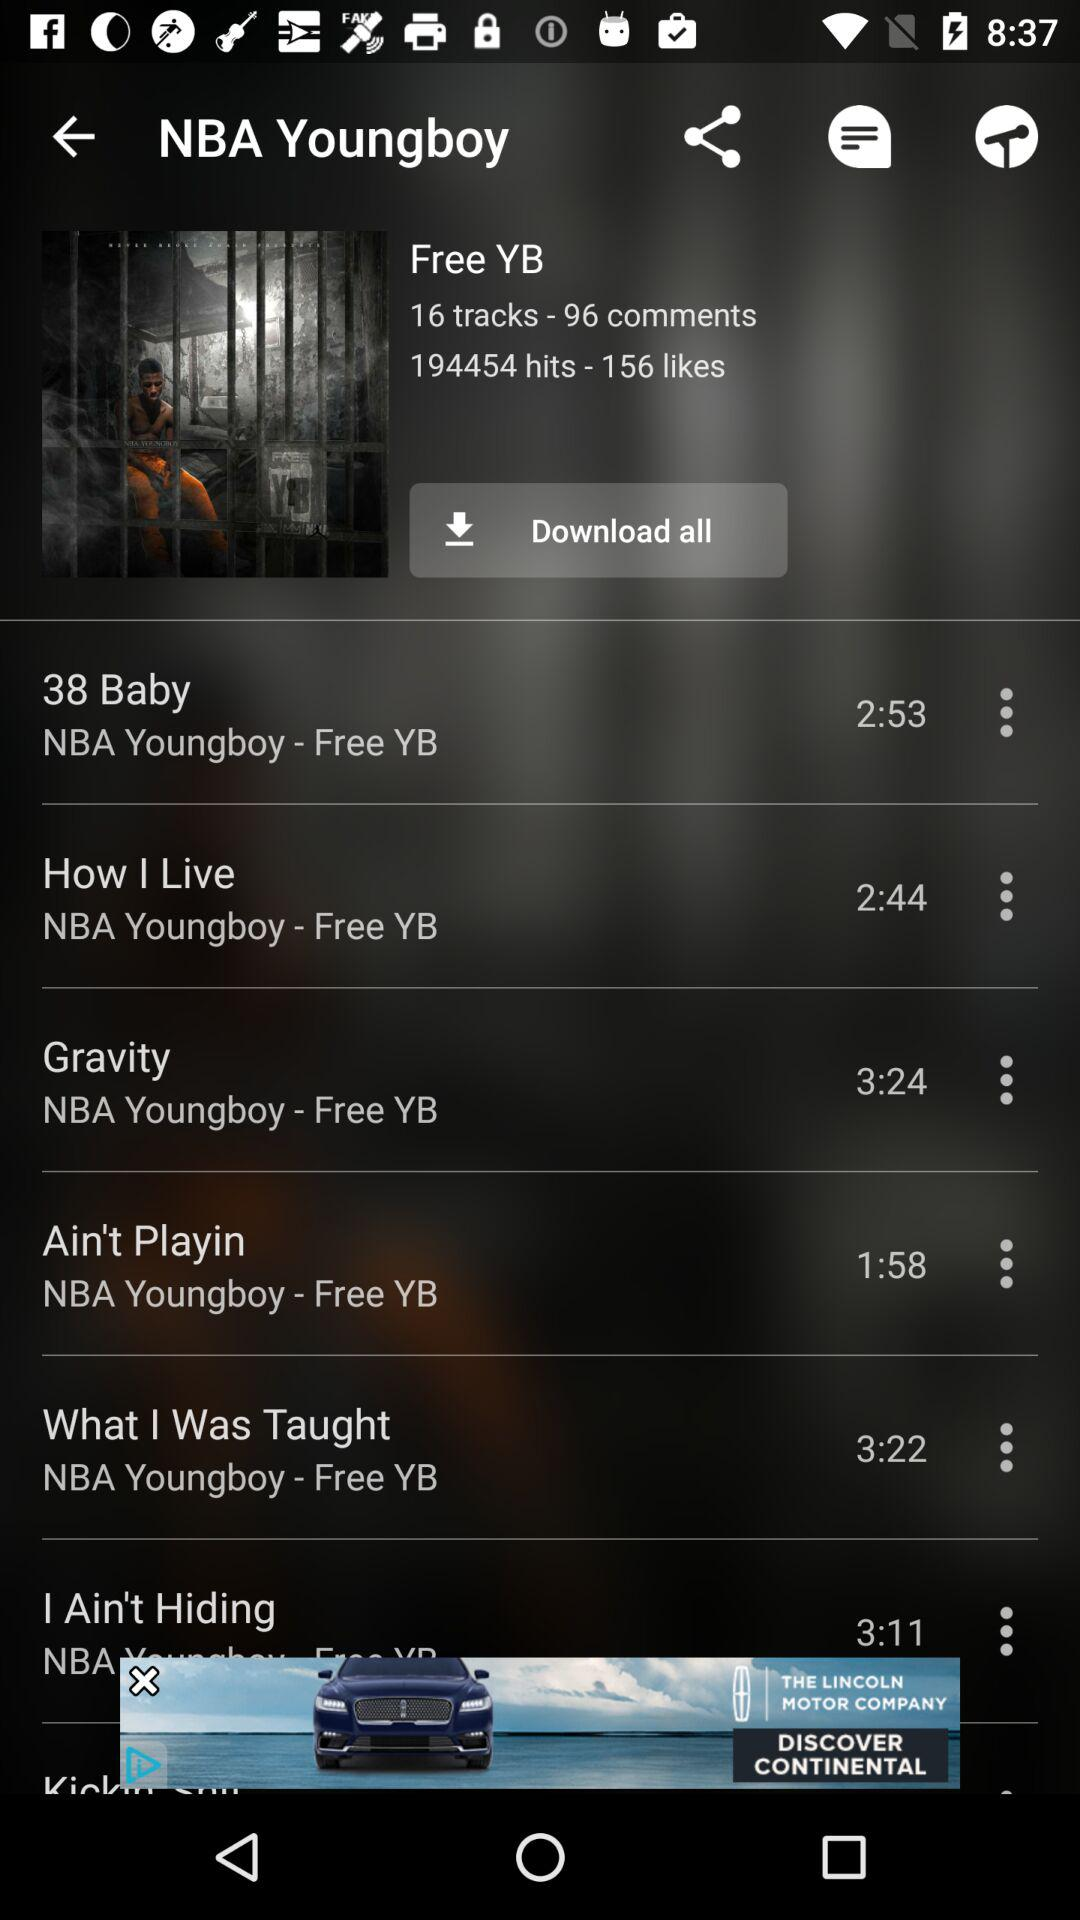What is the duration of the "38 Baby"? The duration of the "38 Baby" is 2:53. 